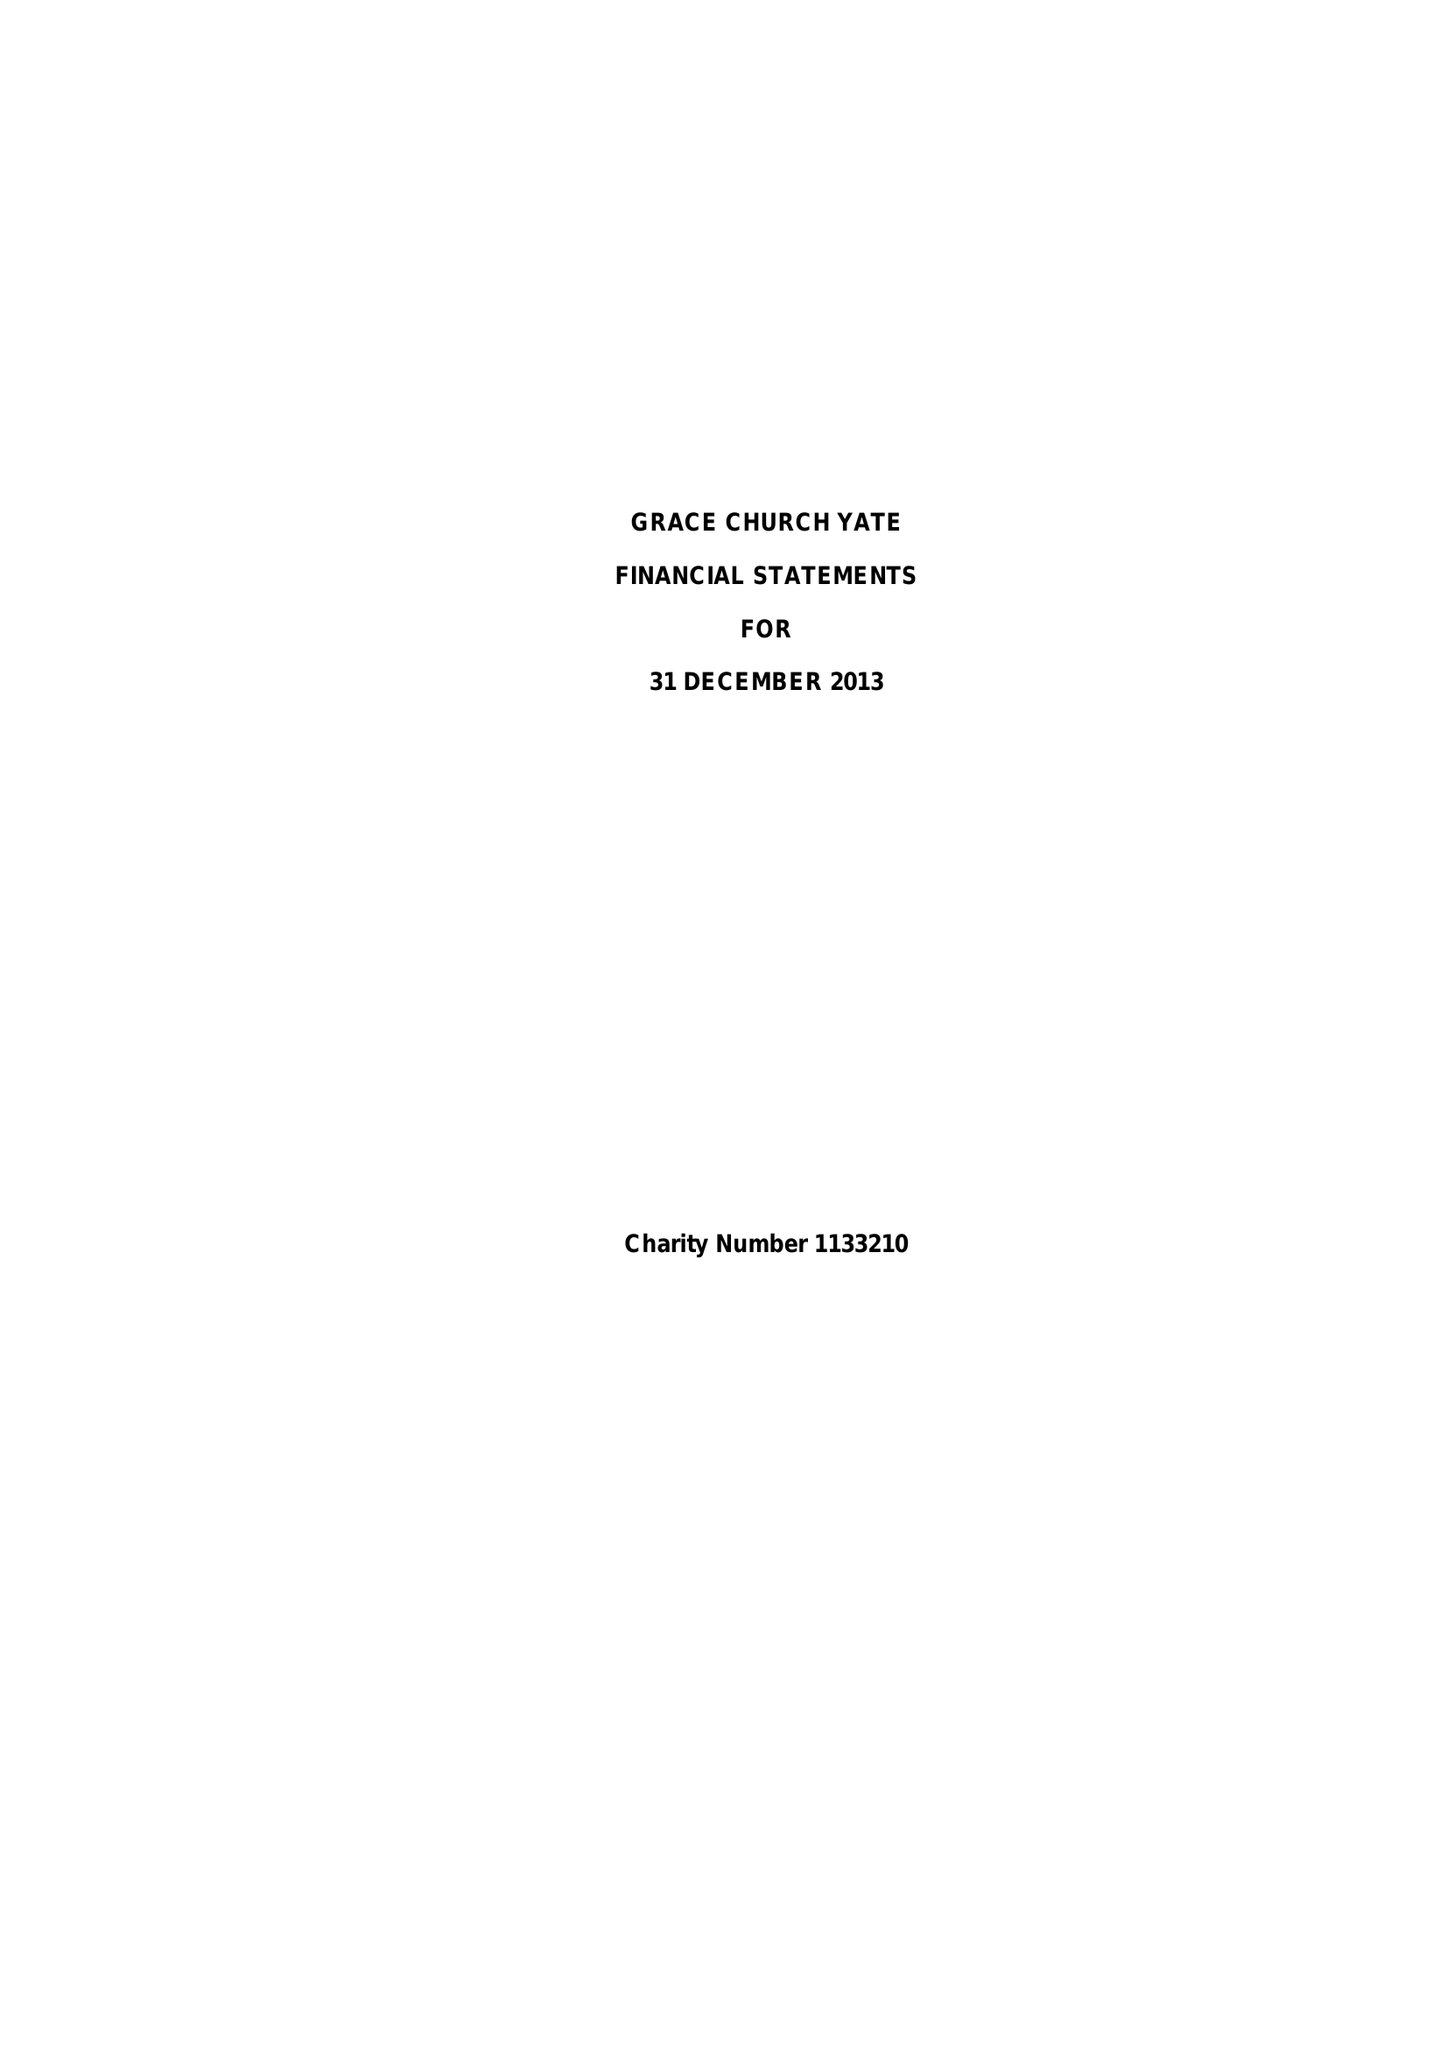What is the value for the address__street_line?
Answer the question using a single word or phrase. 20 FRAMPTON END ROAD 